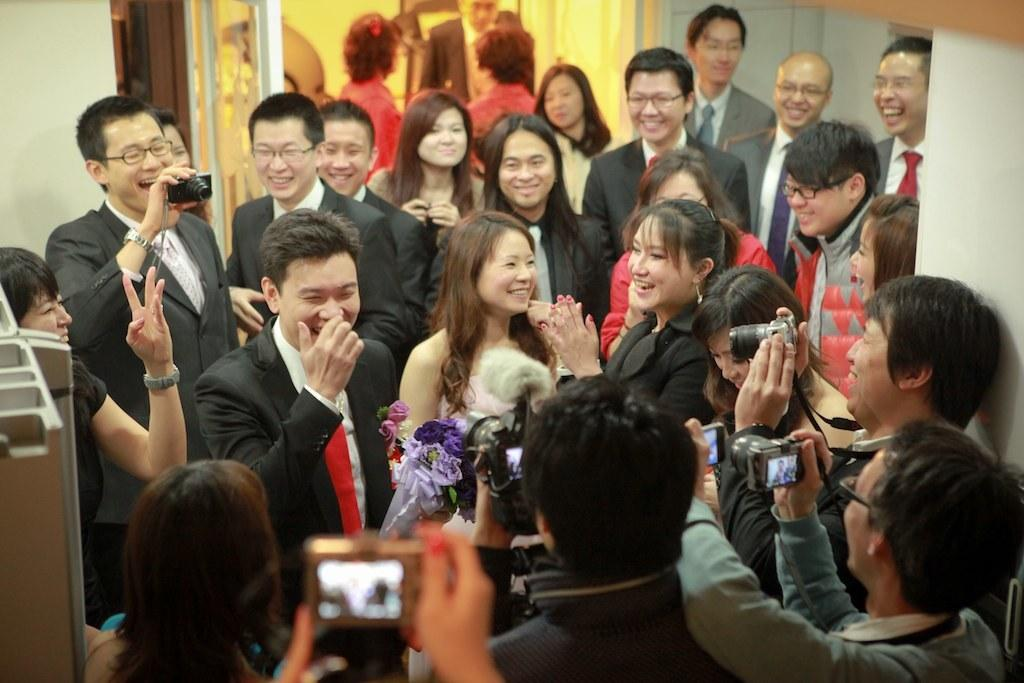Who is present in the image? There are people in the image. What are some of the people doing in the image? Some people are holding cameras in the image. What can be seen in the background of the image? There is a wall visible in the image. What is located on the left side of the image? There are objects on the left side of the image. What color can be observed among the objects in the image? There are white colored objects in the image. What type of apparel is being burned by the people in the image? There is no indication of any apparel being burned in the image. What is the mass of the objects on the left side of the image? The mass of the objects cannot be determined from the image alone. 